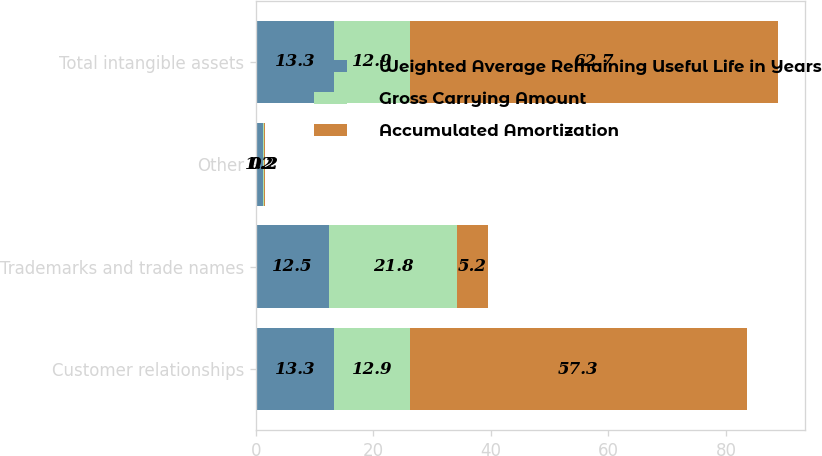Convert chart to OTSL. <chart><loc_0><loc_0><loc_500><loc_500><stacked_bar_chart><ecel><fcel>Customer relationships<fcel>Trademarks and trade names<fcel>Other<fcel>Total intangible assets<nl><fcel>Weighted Average Remaining Useful Life in Years<fcel>13.3<fcel>12.5<fcel>1.2<fcel>13.3<nl><fcel>Gross Carrying Amount<fcel>12.9<fcel>21.8<fcel>0.2<fcel>12.9<nl><fcel>Accumulated Amortization<fcel>57.3<fcel>5.2<fcel>0.2<fcel>62.7<nl></chart> 